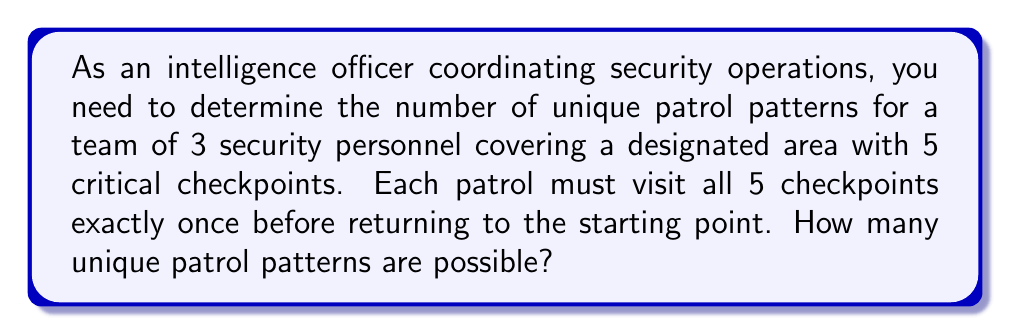Teach me how to tackle this problem. To solve this problem, we need to use the concept of permutations. Here's a step-by-step explanation:

1. First, we need to recognize that this is a circular permutation problem. The patrol starts and ends at the same point, so rotations of the same sequence are considered identical.

2. The number of permutations of $n$ distinct objects in a circle is given by the formula:

   $$(n-1)!$$

3. In this case, we have 5 checkpoints to arrange in a circular pattern, so $n = 5$.

4. Applying the formula:

   $$(5-1)! = 4! = 4 \times 3 \times 2 \times 1 = 24$$

5. However, this calculation assumes that the direction of the patrol doesn't matter. In a security context, clockwise and counterclockwise patrols might be considered distinct.

6. To account for this, we multiply our result by 2:

   $$24 \times 2 = 48$$

Therefore, there are 48 unique patrol patterns possible for the security team.
Answer: 48 unique patrol patterns 